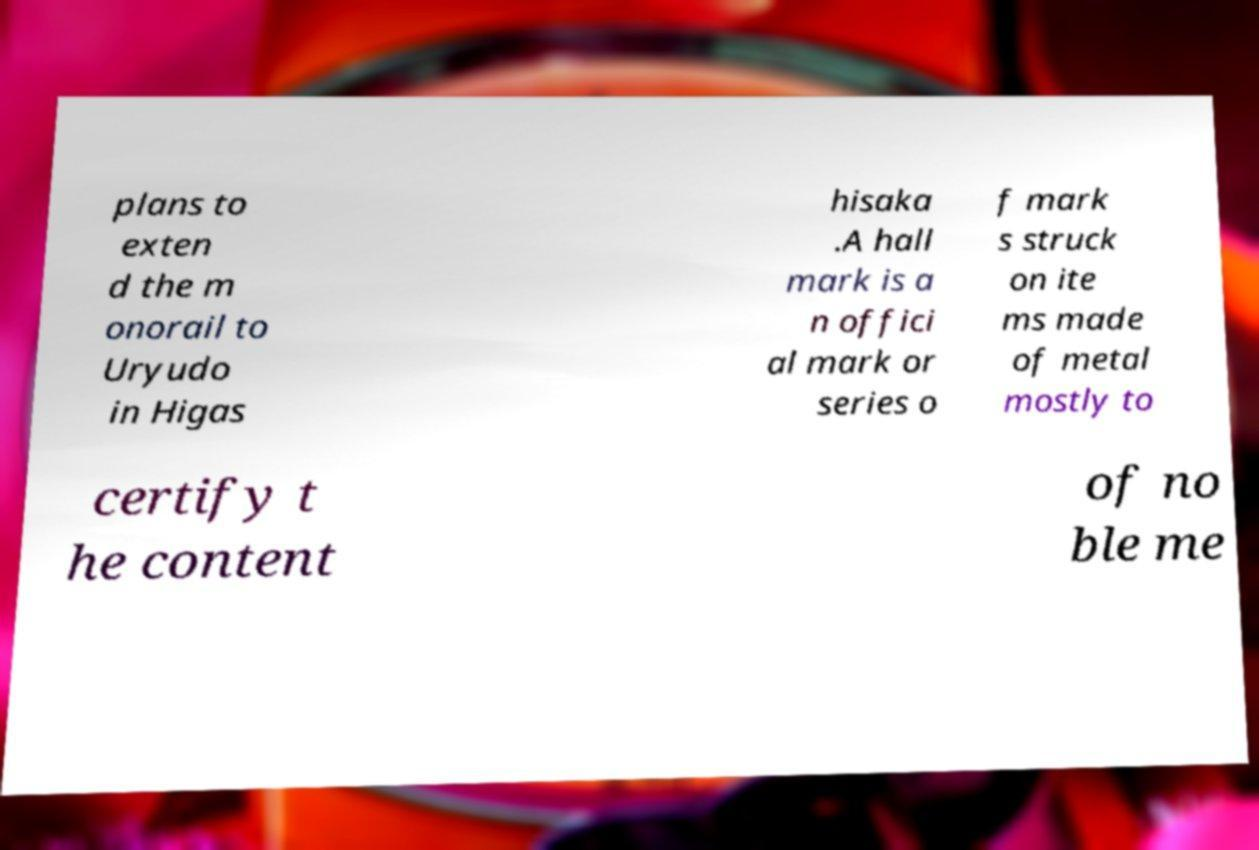Could you assist in decoding the text presented in this image and type it out clearly? plans to exten d the m onorail to Uryudo in Higas hisaka .A hall mark is a n offici al mark or series o f mark s struck on ite ms made of metal mostly to certify t he content of no ble me 